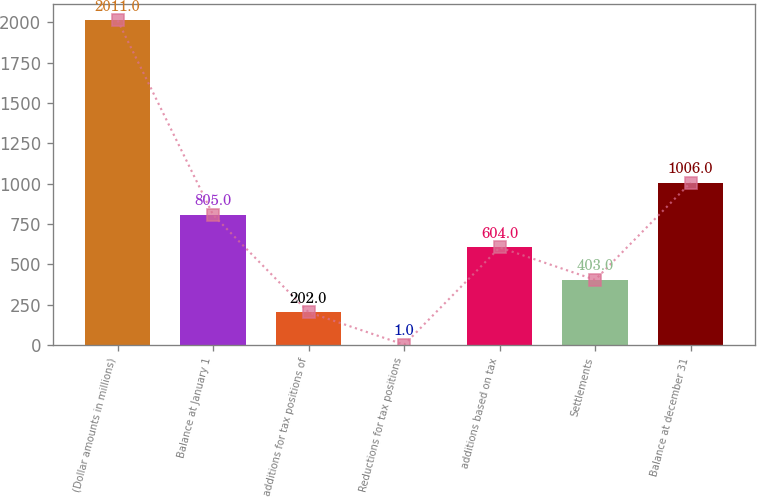<chart> <loc_0><loc_0><loc_500><loc_500><bar_chart><fcel>(Dollar amounts in millions)<fcel>Balance at January 1<fcel>additions for tax positions of<fcel>Reductions for tax positions<fcel>additions based on tax<fcel>Settlements<fcel>Balance at december 31<nl><fcel>2011<fcel>805<fcel>202<fcel>1<fcel>604<fcel>403<fcel>1006<nl></chart> 